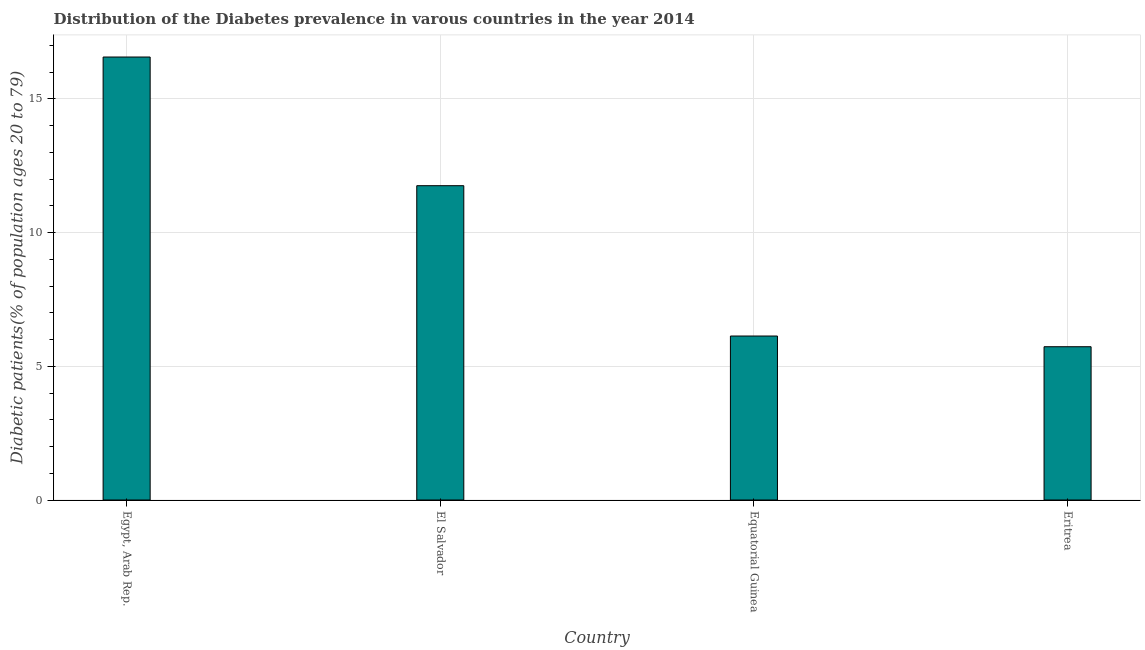What is the title of the graph?
Make the answer very short. Distribution of the Diabetes prevalence in varous countries in the year 2014. What is the label or title of the X-axis?
Provide a short and direct response. Country. What is the label or title of the Y-axis?
Provide a succinct answer. Diabetic patients(% of population ages 20 to 79). What is the number of diabetic patients in El Salvador?
Offer a very short reply. 11.75. Across all countries, what is the maximum number of diabetic patients?
Make the answer very short. 16.56. Across all countries, what is the minimum number of diabetic patients?
Offer a terse response. 5.73. In which country was the number of diabetic patients maximum?
Provide a succinct answer. Egypt, Arab Rep. In which country was the number of diabetic patients minimum?
Keep it short and to the point. Eritrea. What is the sum of the number of diabetic patients?
Make the answer very short. 40.17. What is the difference between the number of diabetic patients in El Salvador and Equatorial Guinea?
Keep it short and to the point. 5.62. What is the average number of diabetic patients per country?
Offer a very short reply. 10.04. What is the median number of diabetic patients?
Provide a succinct answer. 8.94. What is the ratio of the number of diabetic patients in Equatorial Guinea to that in Eritrea?
Offer a terse response. 1.07. What is the difference between the highest and the second highest number of diabetic patients?
Ensure brevity in your answer.  4.81. What is the difference between the highest and the lowest number of diabetic patients?
Make the answer very short. 10.83. How many bars are there?
Your response must be concise. 4. What is the Diabetic patients(% of population ages 20 to 79) in Egypt, Arab Rep.?
Your answer should be compact. 16.56. What is the Diabetic patients(% of population ages 20 to 79) in El Salvador?
Make the answer very short. 11.75. What is the Diabetic patients(% of population ages 20 to 79) in Equatorial Guinea?
Offer a very short reply. 6.13. What is the Diabetic patients(% of population ages 20 to 79) in Eritrea?
Provide a succinct answer. 5.73. What is the difference between the Diabetic patients(% of population ages 20 to 79) in Egypt, Arab Rep. and El Salvador?
Your answer should be very brief. 4.81. What is the difference between the Diabetic patients(% of population ages 20 to 79) in Egypt, Arab Rep. and Equatorial Guinea?
Provide a succinct answer. 10.43. What is the difference between the Diabetic patients(% of population ages 20 to 79) in Egypt, Arab Rep. and Eritrea?
Your answer should be compact. 10.83. What is the difference between the Diabetic patients(% of population ages 20 to 79) in El Salvador and Equatorial Guinea?
Provide a succinct answer. 5.62. What is the difference between the Diabetic patients(% of population ages 20 to 79) in El Salvador and Eritrea?
Ensure brevity in your answer.  6.02. What is the ratio of the Diabetic patients(% of population ages 20 to 79) in Egypt, Arab Rep. to that in El Salvador?
Your response must be concise. 1.41. What is the ratio of the Diabetic patients(% of population ages 20 to 79) in Egypt, Arab Rep. to that in Equatorial Guinea?
Ensure brevity in your answer.  2.7. What is the ratio of the Diabetic patients(% of population ages 20 to 79) in Egypt, Arab Rep. to that in Eritrea?
Provide a succinct answer. 2.89. What is the ratio of the Diabetic patients(% of population ages 20 to 79) in El Salvador to that in Equatorial Guinea?
Your answer should be very brief. 1.92. What is the ratio of the Diabetic patients(% of population ages 20 to 79) in El Salvador to that in Eritrea?
Provide a succinct answer. 2.05. What is the ratio of the Diabetic patients(% of population ages 20 to 79) in Equatorial Guinea to that in Eritrea?
Make the answer very short. 1.07. 